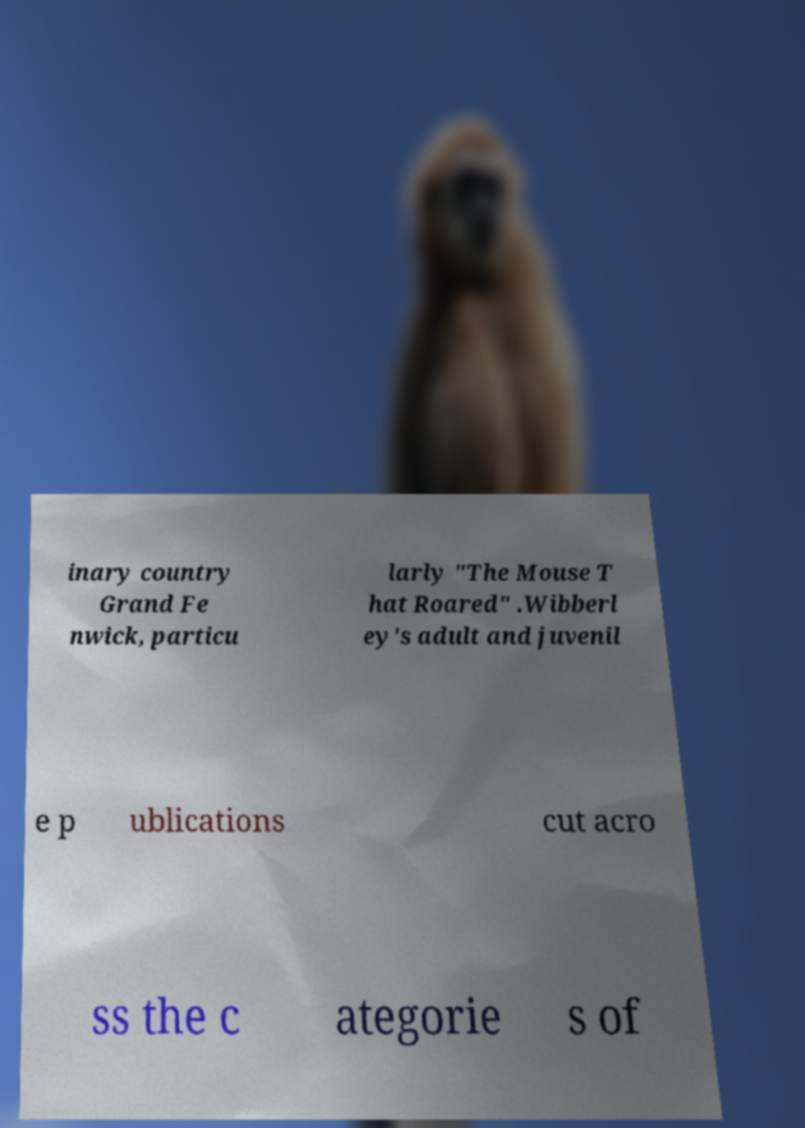Can you read and provide the text displayed in the image?This photo seems to have some interesting text. Can you extract and type it out for me? inary country Grand Fe nwick, particu larly "The Mouse T hat Roared" .Wibberl ey's adult and juvenil e p ublications cut acro ss the c ategorie s of 